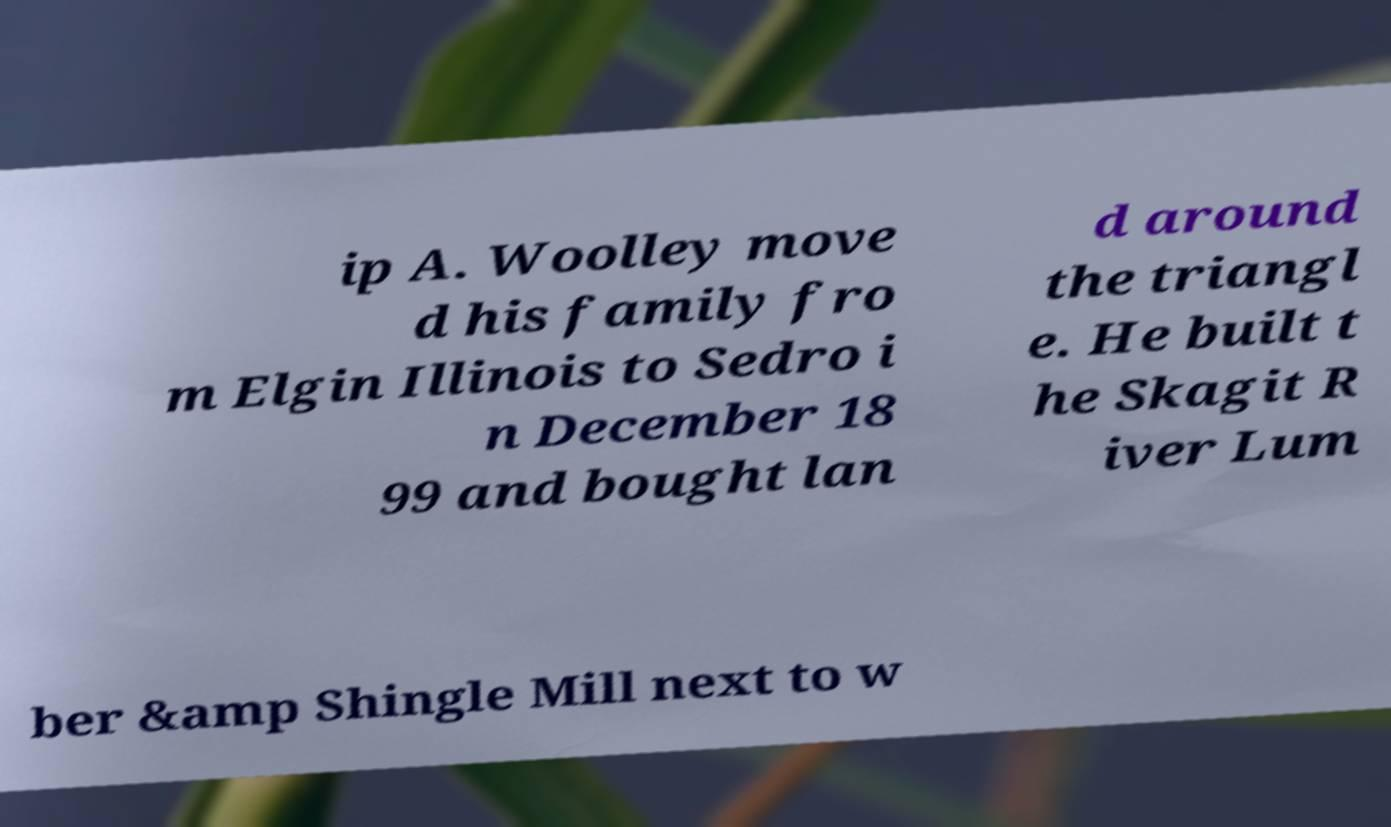Could you extract and type out the text from this image? ip A. Woolley move d his family fro m Elgin Illinois to Sedro i n December 18 99 and bought lan d around the triangl e. He built t he Skagit R iver Lum ber &amp Shingle Mill next to w 